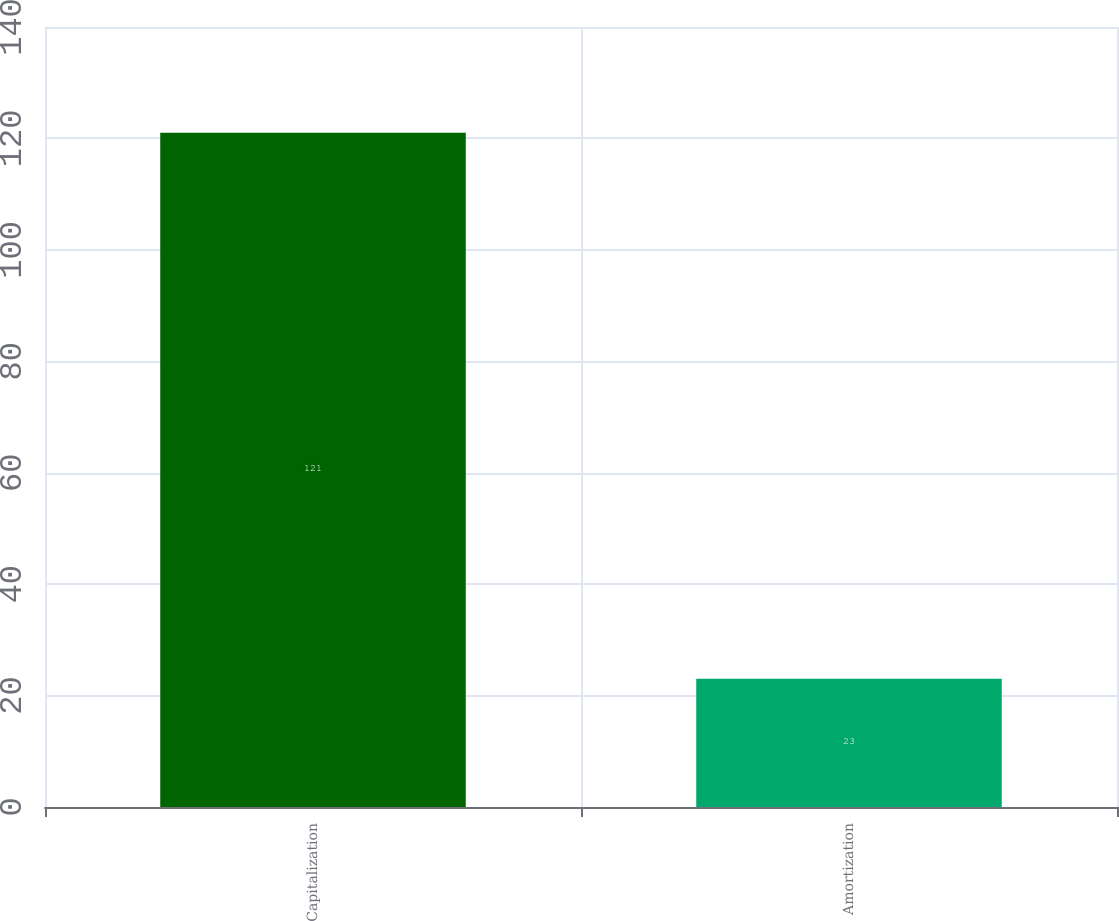Convert chart to OTSL. <chart><loc_0><loc_0><loc_500><loc_500><bar_chart><fcel>Capitalization<fcel>Amortization<nl><fcel>121<fcel>23<nl></chart> 